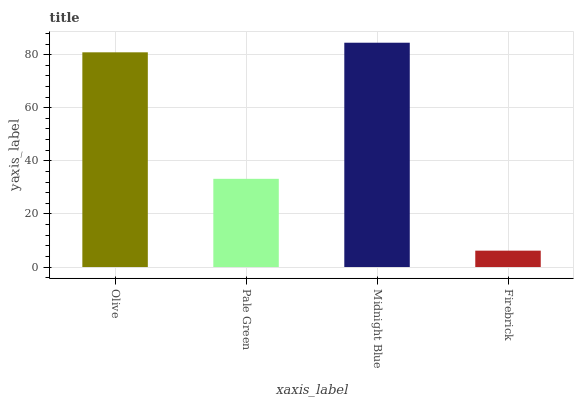Is Firebrick the minimum?
Answer yes or no. Yes. Is Midnight Blue the maximum?
Answer yes or no. Yes. Is Pale Green the minimum?
Answer yes or no. No. Is Pale Green the maximum?
Answer yes or no. No. Is Olive greater than Pale Green?
Answer yes or no. Yes. Is Pale Green less than Olive?
Answer yes or no. Yes. Is Pale Green greater than Olive?
Answer yes or no. No. Is Olive less than Pale Green?
Answer yes or no. No. Is Olive the high median?
Answer yes or no. Yes. Is Pale Green the low median?
Answer yes or no. Yes. Is Firebrick the high median?
Answer yes or no. No. Is Firebrick the low median?
Answer yes or no. No. 